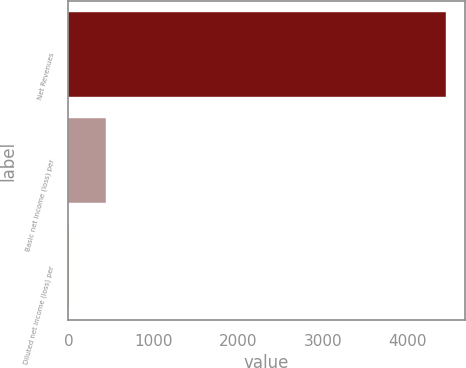Convert chart to OTSL. <chart><loc_0><loc_0><loc_500><loc_500><bar_chart><fcel>Net Revenues<fcel>Basic net income (loss) per<fcel>Diluted net income (loss) per<nl><fcel>4447<fcel>445<fcel>0.33<nl></chart> 